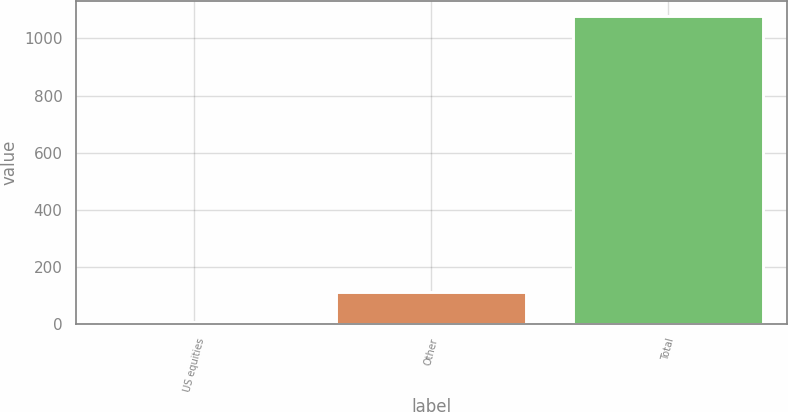<chart> <loc_0><loc_0><loc_500><loc_500><bar_chart><fcel>US equities<fcel>Other<fcel>Total<nl><fcel>5<fcel>112.3<fcel>1078<nl></chart> 